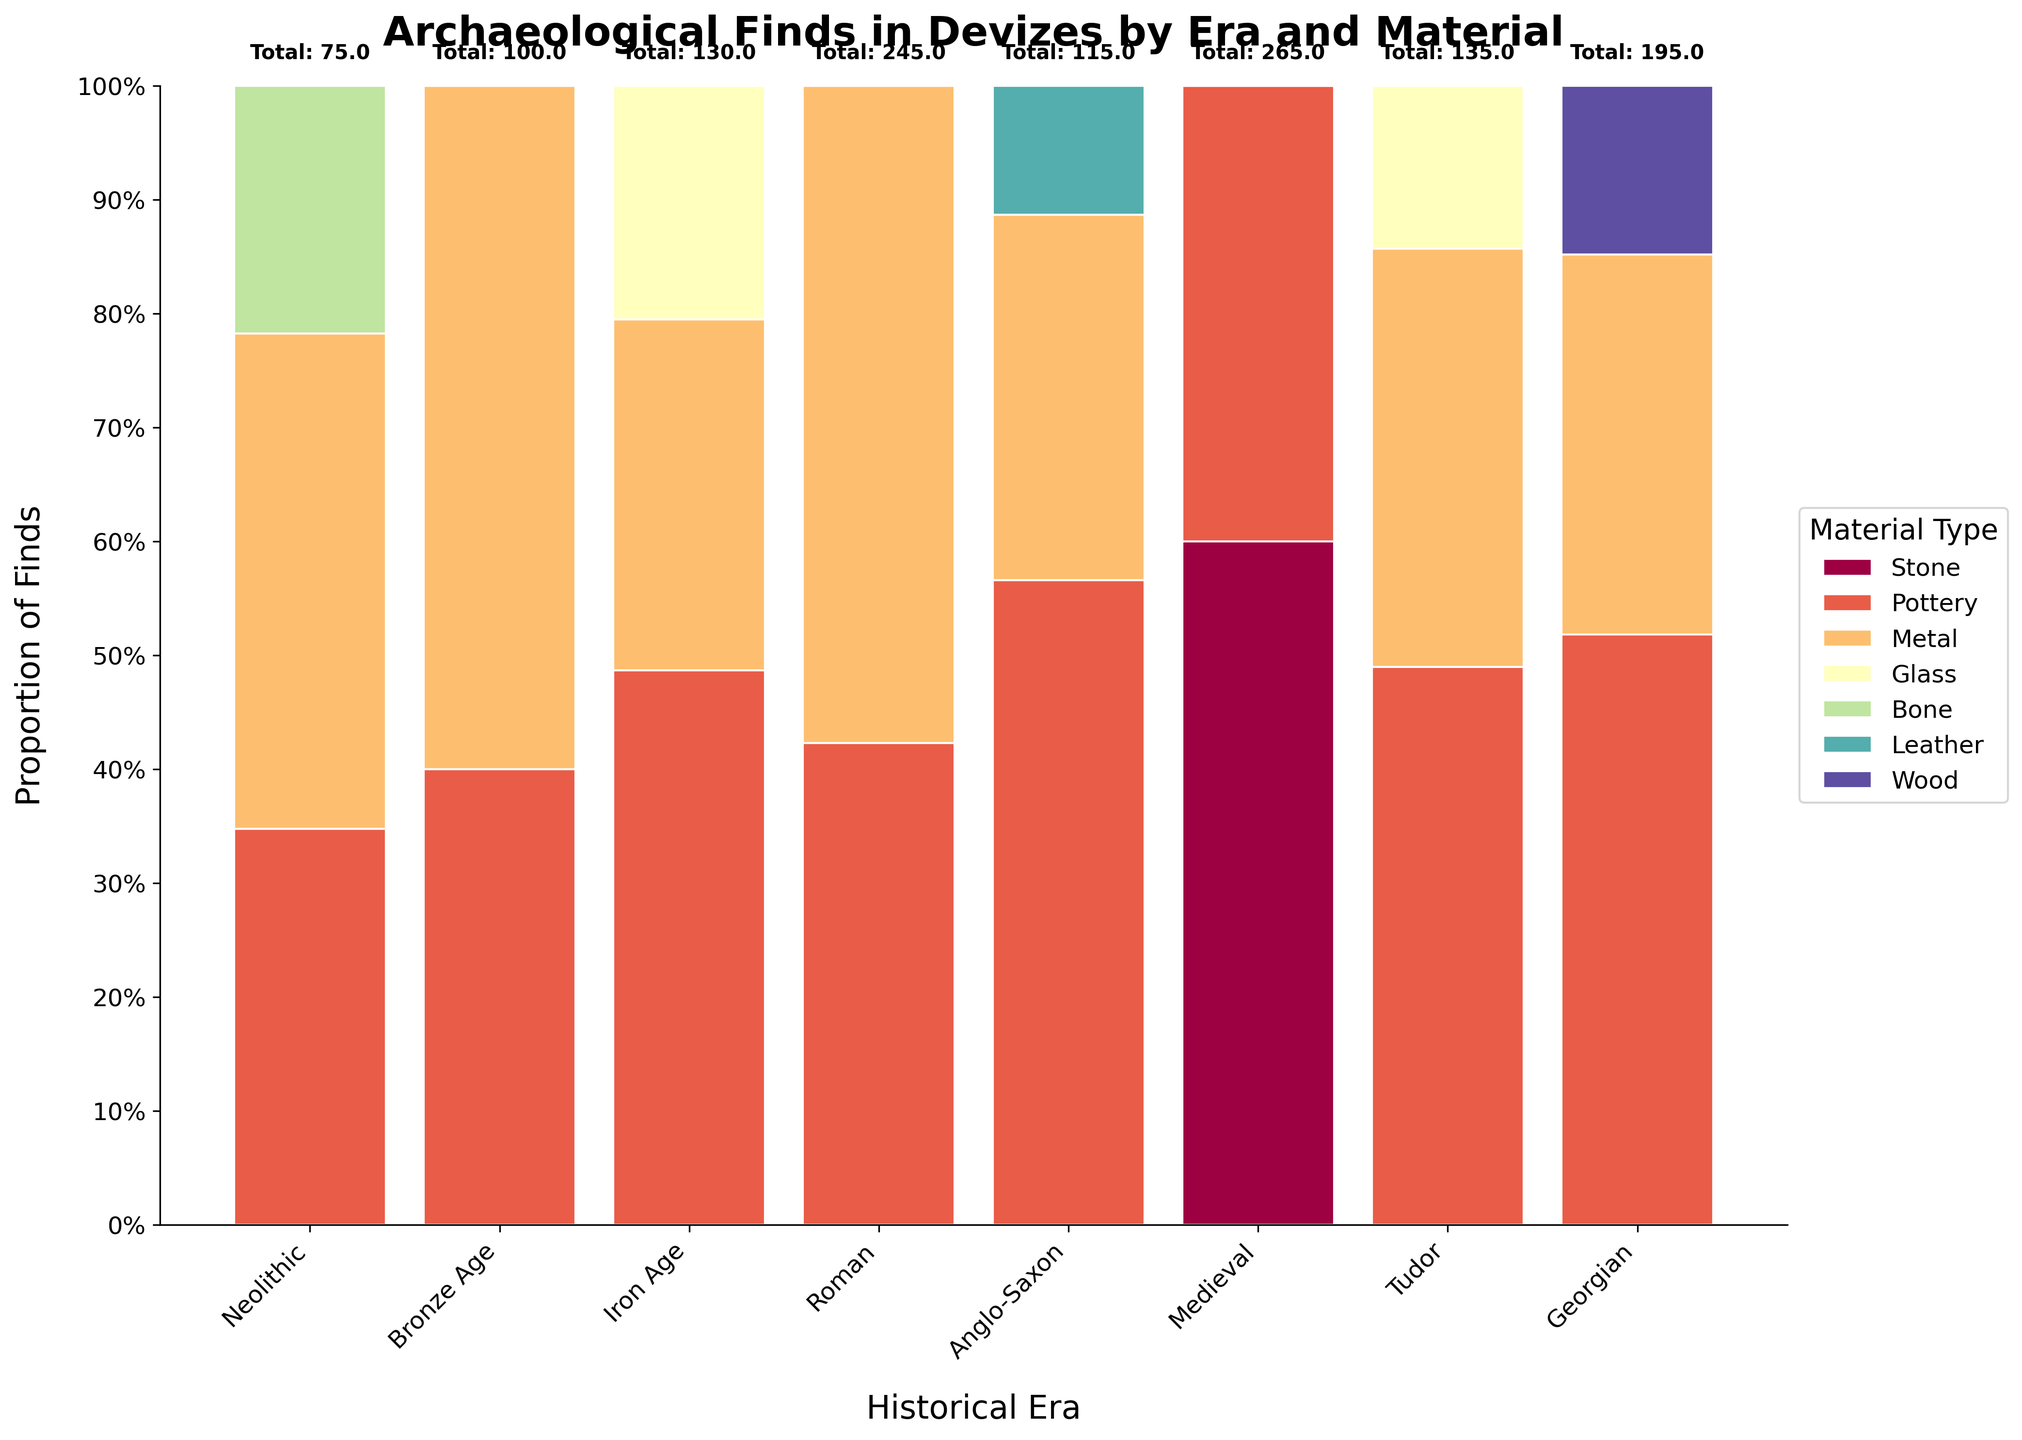What is the title of the figure? The title of the figure is displayed at the top of the plot. It provides a summary of the content of the plot. By looking at the top center of the figure, we can see the title: "Archaeological Finds in Devizes by Era and Material".
Answer: Archaeological Finds in Devizes by Era and Material How many material types are shown in the Iron Age? To determine the number of material types in the Iron Age, look at the section corresponding to the Iron Age on the x-axis. Visual inspection reveals three distinct color segments represented in this era.
Answer: 3 Which historical era has the highest proportion of pottery finds? Identify the columns representing different historical eras on the x-axis. By comparing the height of the segments corresponding to pottery (color-coded consistently) within each column, it is evident that the Medieval era has the largest segment dedicated to pottery.
Answer: Medieval Compare the proportion of metal finds between the Roman and Anglo-Saxon eras. Which era has a higher proportion? Locate the Roman and Anglo-Saxon eras on the x-axis. Then, observe the segment heights for metal within these columns. The Roman era has a taller metal segment compared to the Anglo-Saxon era. Thus, the proportion of metal finds is higher in the Roman era.
Answer: Roman What is the total number of archaeological finds during the Tudor era? Reference the Tudor column on the x-axis. The total count is annotated above this column. The figure shows "Total: 135" for the Tudor era.
Answer: 135 What is the average count of material types in the Bronze Age? The Bronze Age includes segments for Metal and Pottery. The counts are 60 (Metal) and 40 (Pottery). Calculate the average by summing these values (60 + 40 = 100) and dividing by the number of material types (2): 100 / 2 = 50.
Answer: 50 Which material type increases in proportion from the Neolithic to the Roman era? Examine the heights of segments for each material type across the Neolithic to Roman eras. Pottery shows an increasing trend, evident from its growing segment size from Neolithic to Roman eras.
Answer: Pottery During which era do glass finds first appear? Inspect the figure for segments indicating glass finds. The first occurrence is in the Roman era, confirmed by the appearance of a glass segment for this era and absence in previous eras.
Answer: Roman How does the proportion of bone finds in the Anglo-Saxon era compare to other eras? To compare bone finds, first identify its presence in the Anglo-Saxon era. Notably, bone is only present in the Anglo-Saxon era, evidenced by a unique segment color for bone without presence in other eras.
Answer: Anglo-Saxon is the only era with bone finds What is the combined proportion of leather and wood finds in the Tudor era? Locate the Tudor era on the x-axis. Identify and sum the segments for leather and wood. Since leather appears only in the Medieval era and wood only in the Tudor era, wood's segment proportion in the Tudor era is considered alone. Both contribute to their respective single segments' proportions.
Answer: 0% 